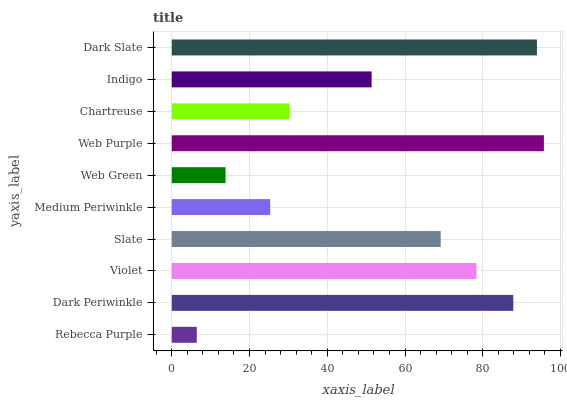Is Rebecca Purple the minimum?
Answer yes or no. Yes. Is Web Purple the maximum?
Answer yes or no. Yes. Is Dark Periwinkle the minimum?
Answer yes or no. No. Is Dark Periwinkle the maximum?
Answer yes or no. No. Is Dark Periwinkle greater than Rebecca Purple?
Answer yes or no. Yes. Is Rebecca Purple less than Dark Periwinkle?
Answer yes or no. Yes. Is Rebecca Purple greater than Dark Periwinkle?
Answer yes or no. No. Is Dark Periwinkle less than Rebecca Purple?
Answer yes or no. No. Is Slate the high median?
Answer yes or no. Yes. Is Indigo the low median?
Answer yes or no. Yes. Is Rebecca Purple the high median?
Answer yes or no. No. Is Chartreuse the low median?
Answer yes or no. No. 